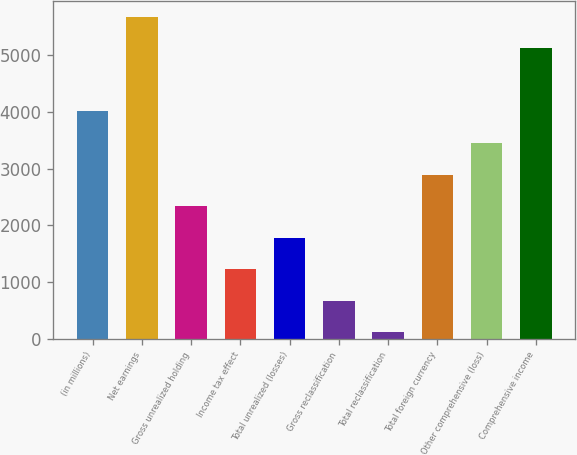Convert chart. <chart><loc_0><loc_0><loc_500><loc_500><bar_chart><fcel>(in millions)<fcel>Net earnings<fcel>Gross unrealized holding<fcel>Income tax effect<fcel>Total unrealized (losses)<fcel>Gross reclassification<fcel>Total reclassification<fcel>Total foreign currency<fcel>Other comprehensive (loss)<fcel>Comprehensive income<nl><fcel>4005.6<fcel>5673<fcel>2338.2<fcel>1226.6<fcel>1782.4<fcel>670.8<fcel>115<fcel>2894<fcel>3449.8<fcel>5117.2<nl></chart> 